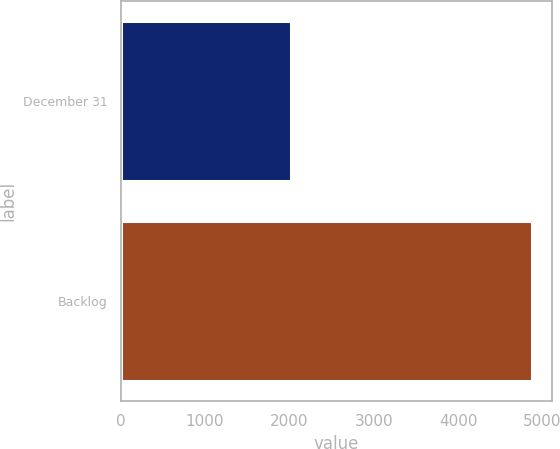Convert chart. <chart><loc_0><loc_0><loc_500><loc_500><bar_chart><fcel>December 31<fcel>Backlog<nl><fcel>2017<fcel>4875<nl></chart> 